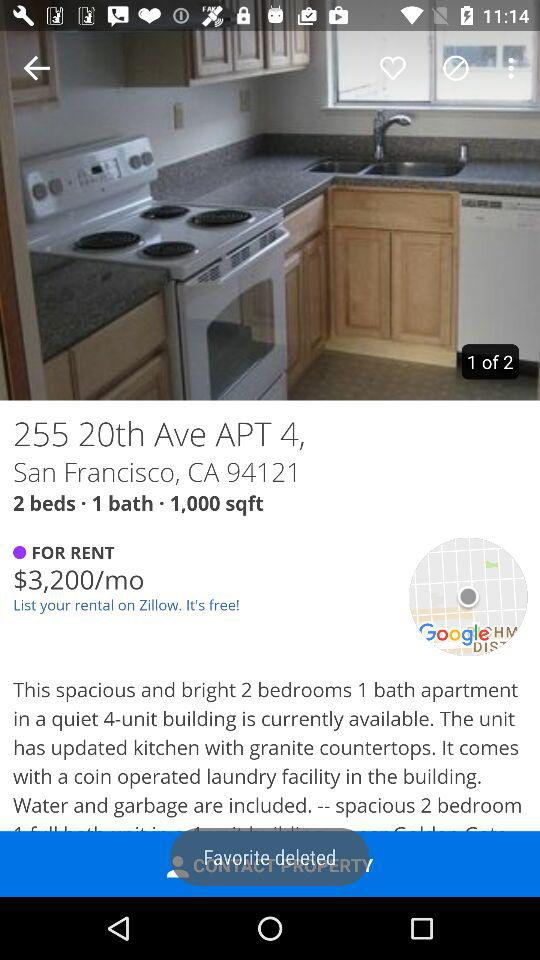How many more bedrooms does this apartment have than bathrooms?
Answer the question using a single word or phrase. 1 